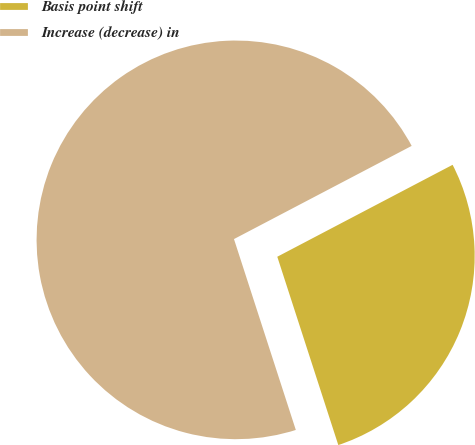Convert chart. <chart><loc_0><loc_0><loc_500><loc_500><pie_chart><fcel>Basis point shift<fcel>Increase (decrease) in<nl><fcel>27.7%<fcel>72.3%<nl></chart> 